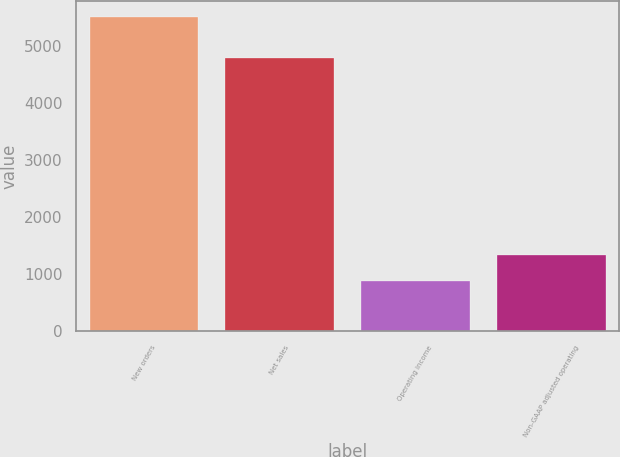Convert chart to OTSL. <chart><loc_0><loc_0><loc_500><loc_500><bar_chart><fcel>New orders<fcel>Net sales<fcel>Operating income<fcel>Non-GAAP adjusted operating<nl><fcel>5507<fcel>4775<fcel>876<fcel>1339.1<nl></chart> 